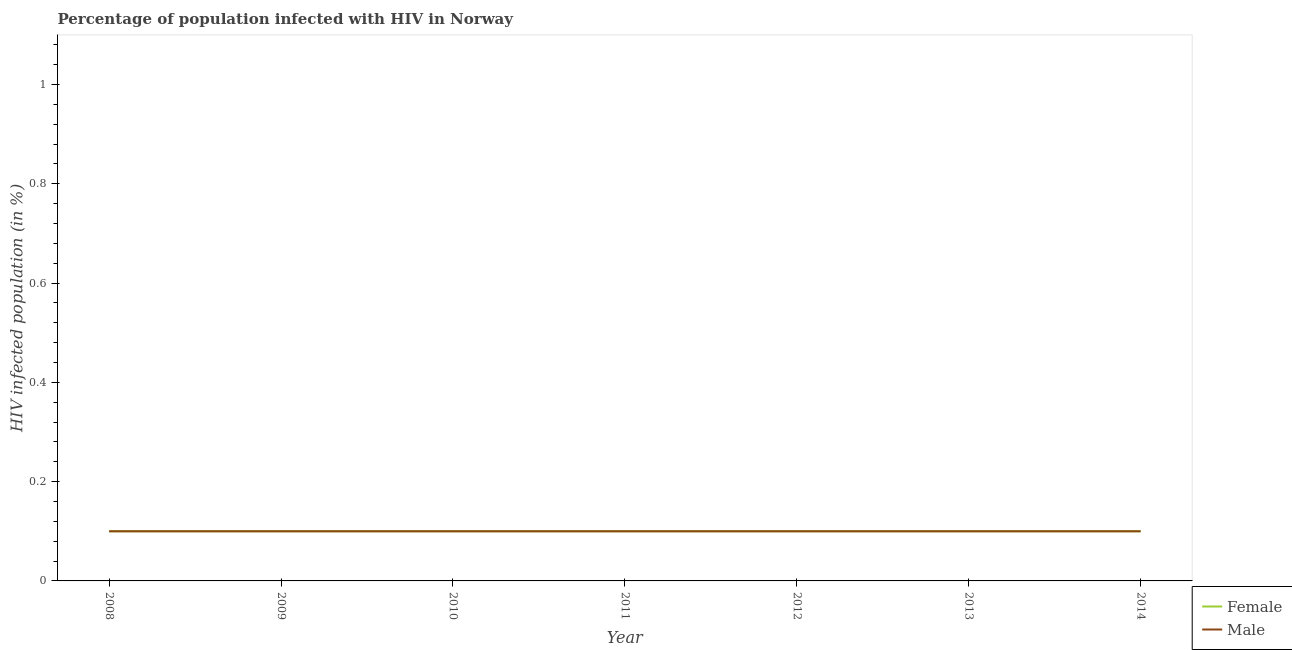Does the line corresponding to percentage of females who are infected with hiv intersect with the line corresponding to percentage of males who are infected with hiv?
Ensure brevity in your answer.  Yes. Is the number of lines equal to the number of legend labels?
Offer a terse response. Yes. In which year was the percentage of males who are infected with hiv minimum?
Offer a terse response. 2008. What is the total percentage of females who are infected with hiv in the graph?
Provide a succinct answer. 0.7. What is the difference between the percentage of females who are infected with hiv in 2013 and the percentage of males who are infected with hiv in 2008?
Make the answer very short. 0. What is the average percentage of females who are infected with hiv per year?
Ensure brevity in your answer.  0.1. In the year 2008, what is the difference between the percentage of males who are infected with hiv and percentage of females who are infected with hiv?
Provide a succinct answer. 0. In how many years, is the percentage of females who are infected with hiv greater than 0.24000000000000002 %?
Keep it short and to the point. 0. What is the difference between the highest and the lowest percentage of males who are infected with hiv?
Make the answer very short. 0. Is the sum of the percentage of males who are infected with hiv in 2008 and 2013 greater than the maximum percentage of females who are infected with hiv across all years?
Make the answer very short. Yes. Is the percentage of males who are infected with hiv strictly less than the percentage of females who are infected with hiv over the years?
Provide a short and direct response. No. How many years are there in the graph?
Offer a very short reply. 7. What is the difference between two consecutive major ticks on the Y-axis?
Give a very brief answer. 0.2. How are the legend labels stacked?
Your response must be concise. Vertical. What is the title of the graph?
Your response must be concise. Percentage of population infected with HIV in Norway. What is the label or title of the Y-axis?
Offer a very short reply. HIV infected population (in %). What is the HIV infected population (in %) of Female in 2008?
Give a very brief answer. 0.1. What is the HIV infected population (in %) in Female in 2009?
Provide a succinct answer. 0.1. What is the HIV infected population (in %) of Male in 2009?
Your response must be concise. 0.1. What is the HIV infected population (in %) in Male in 2011?
Your answer should be compact. 0.1. What is the HIV infected population (in %) of Female in 2012?
Ensure brevity in your answer.  0.1. What is the HIV infected population (in %) in Male in 2012?
Provide a short and direct response. 0.1. What is the HIV infected population (in %) of Female in 2013?
Offer a terse response. 0.1. What is the HIV infected population (in %) of Male in 2013?
Provide a succinct answer. 0.1. What is the HIV infected population (in %) of Female in 2014?
Offer a very short reply. 0.1. Across all years, what is the maximum HIV infected population (in %) of Male?
Provide a succinct answer. 0.1. What is the total HIV infected population (in %) in Female in the graph?
Provide a succinct answer. 0.7. What is the difference between the HIV infected population (in %) of Male in 2008 and that in 2011?
Provide a succinct answer. 0. What is the difference between the HIV infected population (in %) in Male in 2008 and that in 2012?
Make the answer very short. 0. What is the difference between the HIV infected population (in %) of Female in 2008 and that in 2013?
Provide a succinct answer. 0. What is the difference between the HIV infected population (in %) in Male in 2008 and that in 2014?
Keep it short and to the point. 0. What is the difference between the HIV infected population (in %) in Male in 2009 and that in 2010?
Give a very brief answer. 0. What is the difference between the HIV infected population (in %) of Female in 2009 and that in 2011?
Ensure brevity in your answer.  0. What is the difference between the HIV infected population (in %) in Male in 2009 and that in 2011?
Ensure brevity in your answer.  0. What is the difference between the HIV infected population (in %) in Male in 2009 and that in 2012?
Offer a terse response. 0. What is the difference between the HIV infected population (in %) in Female in 2009 and that in 2013?
Your response must be concise. 0. What is the difference between the HIV infected population (in %) of Male in 2009 and that in 2013?
Your answer should be compact. 0. What is the difference between the HIV infected population (in %) in Female in 2009 and that in 2014?
Keep it short and to the point. 0. What is the difference between the HIV infected population (in %) of Female in 2010 and that in 2011?
Make the answer very short. 0. What is the difference between the HIV infected population (in %) in Female in 2010 and that in 2012?
Offer a terse response. 0. What is the difference between the HIV infected population (in %) in Female in 2010 and that in 2013?
Keep it short and to the point. 0. What is the difference between the HIV infected population (in %) in Male in 2010 and that in 2013?
Give a very brief answer. 0. What is the difference between the HIV infected population (in %) in Female in 2010 and that in 2014?
Your response must be concise. 0. What is the difference between the HIV infected population (in %) of Male in 2010 and that in 2014?
Provide a short and direct response. 0. What is the difference between the HIV infected population (in %) of Female in 2011 and that in 2012?
Offer a terse response. 0. What is the difference between the HIV infected population (in %) of Male in 2011 and that in 2013?
Your answer should be very brief. 0. What is the difference between the HIV infected population (in %) in Female in 2011 and that in 2014?
Offer a very short reply. 0. What is the difference between the HIV infected population (in %) in Male in 2012 and that in 2013?
Provide a short and direct response. 0. What is the difference between the HIV infected population (in %) in Female in 2012 and that in 2014?
Keep it short and to the point. 0. What is the difference between the HIV infected population (in %) of Female in 2008 and the HIV infected population (in %) of Male in 2010?
Offer a terse response. 0. What is the difference between the HIV infected population (in %) of Female in 2008 and the HIV infected population (in %) of Male in 2011?
Your answer should be very brief. 0. What is the difference between the HIV infected population (in %) in Female in 2009 and the HIV infected population (in %) in Male in 2014?
Offer a very short reply. 0. What is the difference between the HIV infected population (in %) of Female in 2011 and the HIV infected population (in %) of Male in 2013?
Provide a short and direct response. 0. What is the difference between the HIV infected population (in %) of Female in 2011 and the HIV infected population (in %) of Male in 2014?
Provide a succinct answer. 0. What is the difference between the HIV infected population (in %) of Female in 2012 and the HIV infected population (in %) of Male in 2014?
Ensure brevity in your answer.  0. In the year 2010, what is the difference between the HIV infected population (in %) of Female and HIV infected population (in %) of Male?
Provide a short and direct response. 0. In the year 2011, what is the difference between the HIV infected population (in %) in Female and HIV infected population (in %) in Male?
Your answer should be very brief. 0. In the year 2012, what is the difference between the HIV infected population (in %) in Female and HIV infected population (in %) in Male?
Your response must be concise. 0. In the year 2013, what is the difference between the HIV infected population (in %) of Female and HIV infected population (in %) of Male?
Your answer should be very brief. 0. What is the ratio of the HIV infected population (in %) in Female in 2008 to that in 2009?
Provide a short and direct response. 1. What is the ratio of the HIV infected population (in %) of Female in 2008 to that in 2010?
Ensure brevity in your answer.  1. What is the ratio of the HIV infected population (in %) in Female in 2008 to that in 2011?
Offer a very short reply. 1. What is the ratio of the HIV infected population (in %) of Female in 2008 to that in 2012?
Make the answer very short. 1. What is the ratio of the HIV infected population (in %) in Male in 2008 to that in 2012?
Ensure brevity in your answer.  1. What is the ratio of the HIV infected population (in %) of Female in 2008 to that in 2013?
Make the answer very short. 1. What is the ratio of the HIV infected population (in %) of Male in 2008 to that in 2013?
Ensure brevity in your answer.  1. What is the ratio of the HIV infected population (in %) in Male in 2009 to that in 2010?
Your answer should be compact. 1. What is the ratio of the HIV infected population (in %) of Female in 2009 to that in 2011?
Ensure brevity in your answer.  1. What is the ratio of the HIV infected population (in %) of Male in 2009 to that in 2011?
Ensure brevity in your answer.  1. What is the ratio of the HIV infected population (in %) in Male in 2009 to that in 2012?
Offer a very short reply. 1. What is the ratio of the HIV infected population (in %) of Female in 2009 to that in 2014?
Make the answer very short. 1. What is the ratio of the HIV infected population (in %) in Male in 2009 to that in 2014?
Your answer should be very brief. 1. What is the ratio of the HIV infected population (in %) of Female in 2010 to that in 2011?
Keep it short and to the point. 1. What is the ratio of the HIV infected population (in %) of Male in 2010 to that in 2011?
Provide a succinct answer. 1. What is the ratio of the HIV infected population (in %) of Male in 2010 to that in 2013?
Offer a very short reply. 1. What is the ratio of the HIV infected population (in %) in Female in 2010 to that in 2014?
Your answer should be very brief. 1. What is the ratio of the HIV infected population (in %) in Male in 2010 to that in 2014?
Offer a terse response. 1. What is the ratio of the HIV infected population (in %) of Female in 2011 to that in 2012?
Provide a succinct answer. 1. What is the ratio of the HIV infected population (in %) of Male in 2011 to that in 2012?
Give a very brief answer. 1. What is the ratio of the HIV infected population (in %) of Female in 2011 to that in 2013?
Offer a terse response. 1. What is the ratio of the HIV infected population (in %) of Female in 2012 to that in 2013?
Ensure brevity in your answer.  1. What is the ratio of the HIV infected population (in %) in Female in 2012 to that in 2014?
Keep it short and to the point. 1. What is the ratio of the HIV infected population (in %) in Female in 2013 to that in 2014?
Give a very brief answer. 1. 